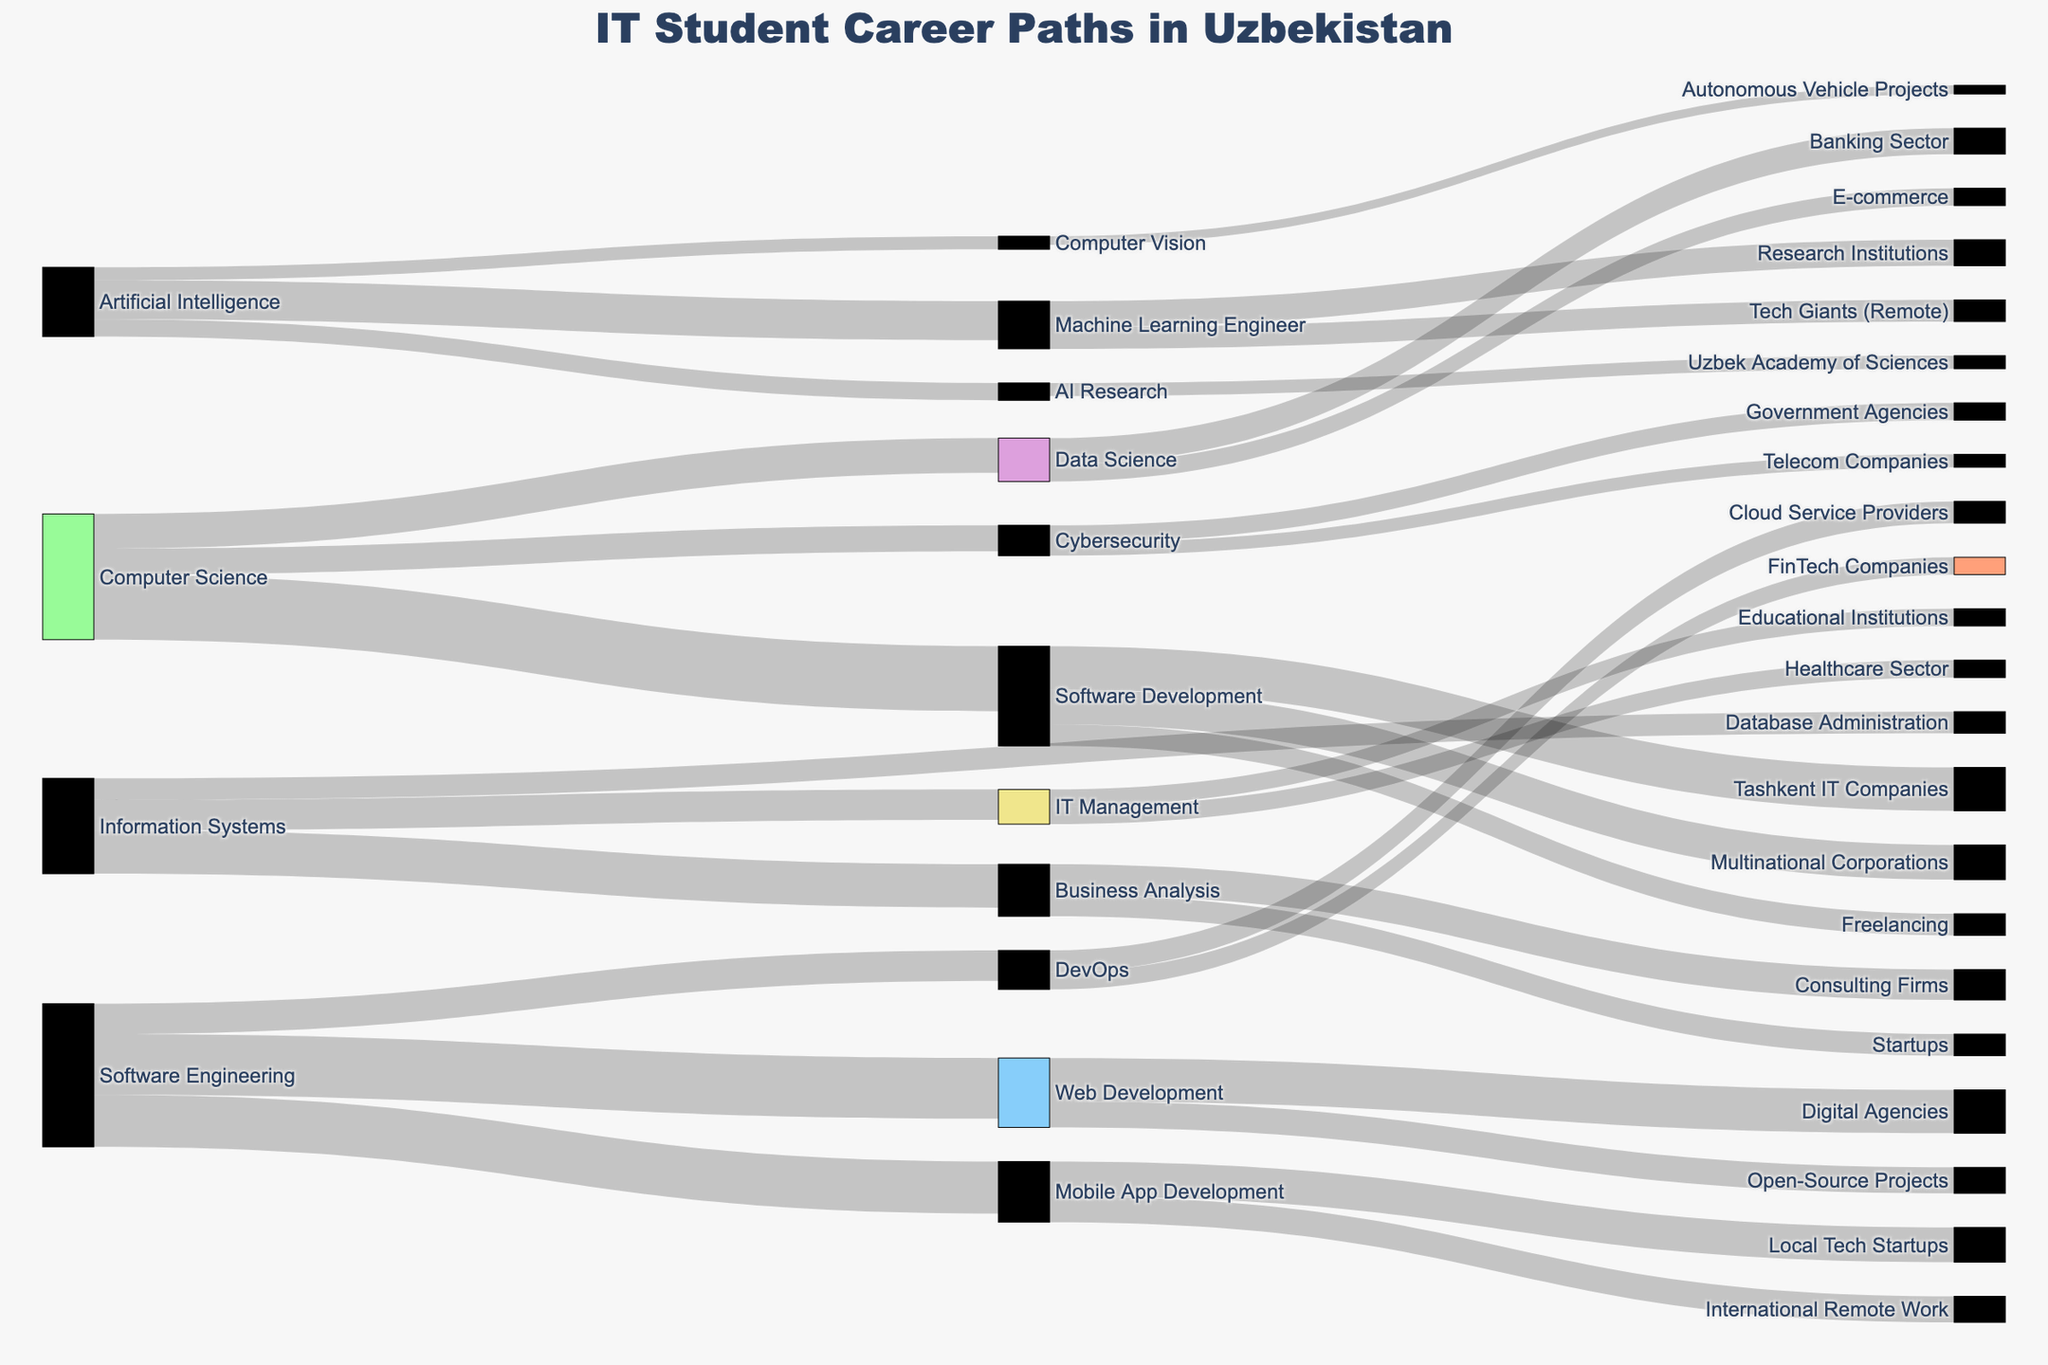What major has the most students going into Software Development? The Sankey diagram shows the flow of students from different majors to various job roles. The width of the bands indicates the number of students. The Computer Science major has the widest band flowing into Software Development.
Answer: Computer Science What is the total number of students pursuing careers in Artificial Intelligence-related fields? To find the total number of students in Artificial Intelligence-related fields, we sum the value from Artificial Intelligence to Machine Learning Engineer, AI Research, and Computer Vision, which are 90, 40, and 30 respectively.
Answer: 160 Which job placement receives more students: E-commerce (from Data Science) or Open-Source Projects (from Web Development)? By comparing the value flowing into E-commerce (40) and Open-Source Projects (60), we see that more students from Web Development go into Open-Source Projects than students from Data Science going into E-commerce.
Answer: Open-Source Projects What is the combined total of students from Information Systems going into Business Analysis and IT Management? To find the combined total, add the values for Business Analysis (100) and IT Management (70) from Information Systems.
Answer: 170 Which career path attracts more students: DevOps from Software Engineering or Cybersecurity from Computer Science? By comparing the values DevOps (70) and Cybersecurity (60), we see more students from Software Engineering transition to DevOps than students from Computer Science to Cybersecurity.
Answer: DevOps How many students join Tashkent IT Companies and Multinational Corporations after Software Development? By adding the values flowing into Tashkent IT Companies (100) and Multinational Corporations (80) from Software Development, we get the total number of students.
Answer: 180 Which field has the fewest students: AI Research or Computer Vision? Comparing the values of AI Research (40) and Computer Vision (30), Computer Vision has fewer students.
Answer: Computer Vision What is the difference in the number of students between those going into Local Tech Startups and International Remote Work from Mobile App Development? The difference can be calculated by subtracting the value for International Remote Work (60) from Local Tech Startups (80).
Answer: 20 Is the number of students choosing to freelance after Software Development greater or less than those working in the Healthcare Sector from IT Management? The values for Freelancing (50) and Healthcare Sector (40) are compared, showing that more students choose to freelance after Software Development than work in the Healthcare Sector from IT Management.
Answer: Greater What is the ratio of students going from Computer Science to Software Development compared to those going into Cybersecurity? The ratio can be found by dividing the number of students going into Software Development (150) by those going into Cybersecurity (60).
Answer: 2.5:1 